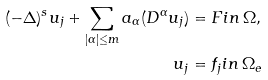<formula> <loc_0><loc_0><loc_500><loc_500>( - \Delta ) ^ { s } u _ { j } + \sum _ { | \alpha | \leq m } a _ { \alpha } ( D ^ { \alpha } u _ { j } ) & = F i n \, \Omega , \\ u _ { j } & = f _ { j } i n \, \Omega _ { e }</formula> 